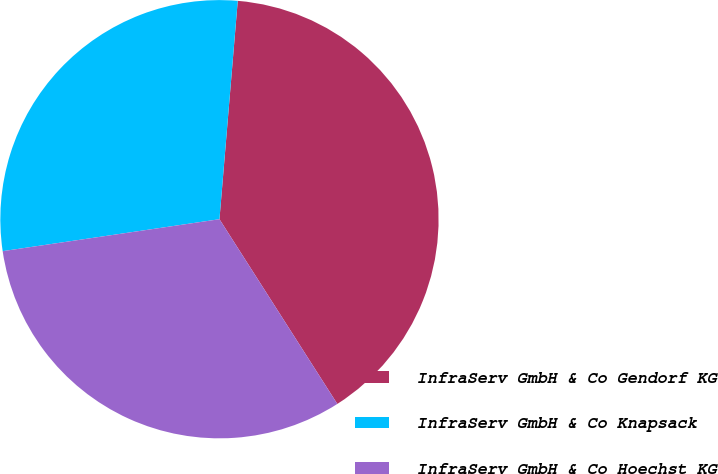<chart> <loc_0><loc_0><loc_500><loc_500><pie_chart><fcel>InfraServ GmbH & Co Gendorf KG<fcel>InfraServ GmbH & Co Knapsack<fcel>InfraServ GmbH & Co Hoechst KG<nl><fcel>39.63%<fcel>28.66%<fcel>31.71%<nl></chart> 